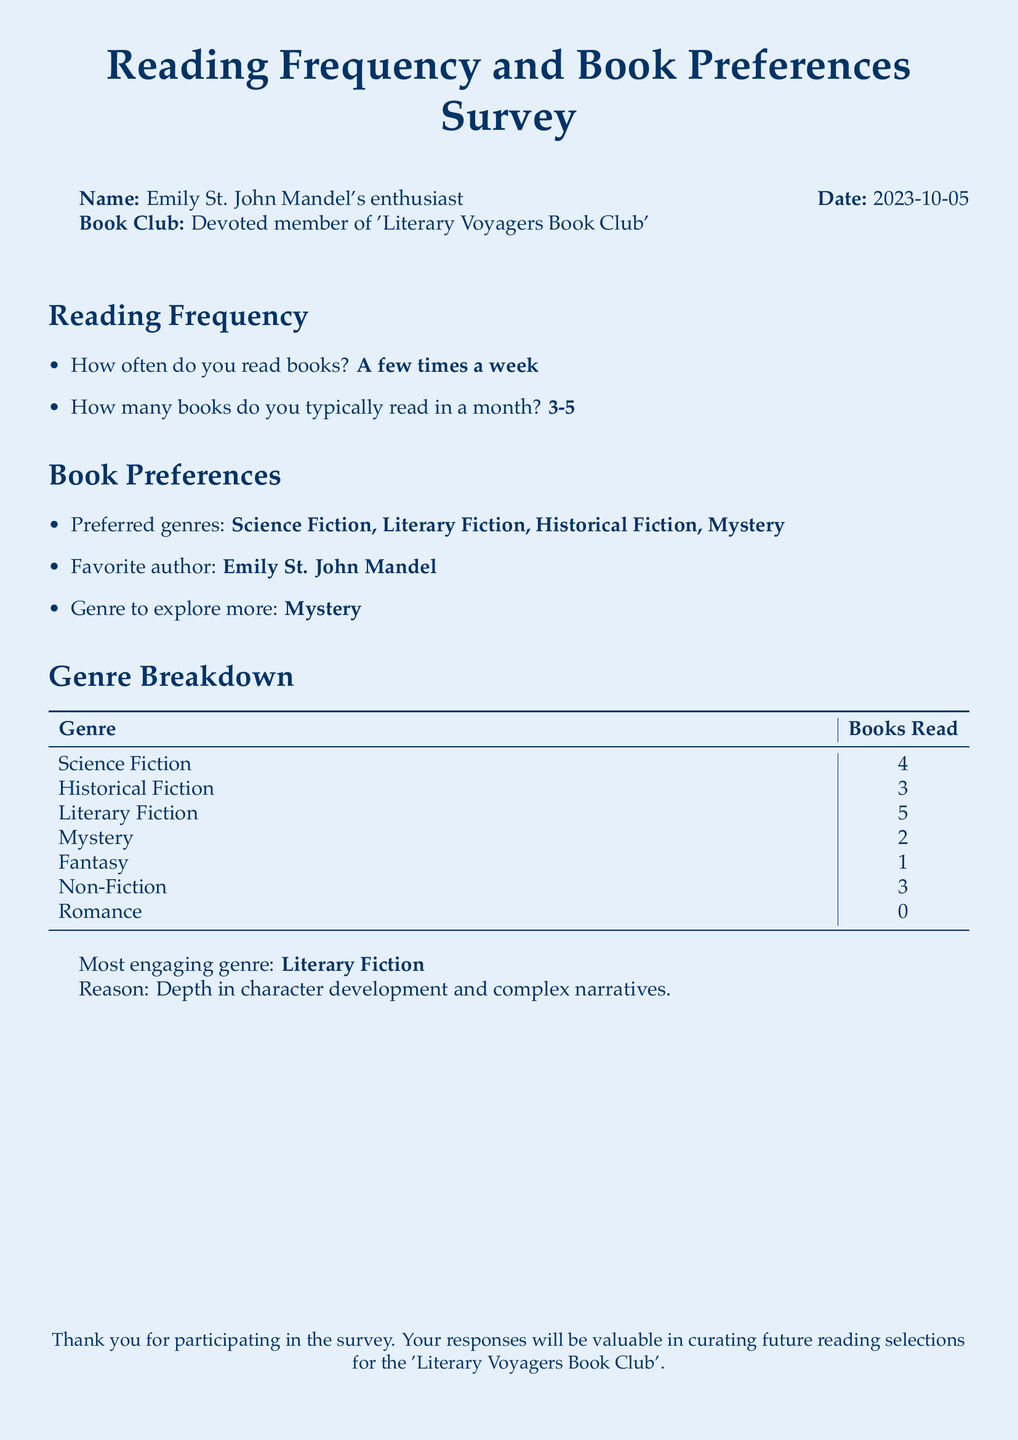What is the name of the survey participant? The name of the survey participant is mentioned explicitly at the top of the document.
Answer: Emily St. John Mandel's enthusiast What is the date of the survey? The date is provided in the document as part of the participant's information.
Answer: 2023-10-05 How many books does the participant read typically in a month? This information is directly provided in the Reading Frequency section of the document.
Answer: 3-5 What is the favorite author of the participant? The favorite author is stated in the Book Preferences section.
Answer: Emily St. John Mandel Which genre does the participant want to explore more? The genre to explore more is specified in the Book Preferences section.
Answer: Mystery How many Science Fiction books has the participant read? The number of Science Fiction books read is listed in the Genre Breakdown table.
Answer: 4 What is the most engaging genre as per the survey participant? This is mentioned at the end of the Genre Breakdown section.
Answer: Literary Fiction What reason does the participant provide for their most engaging genre? The reason is given in the text following the table under Genre Breakdown.
Answer: Depth in character development and complex narratives 